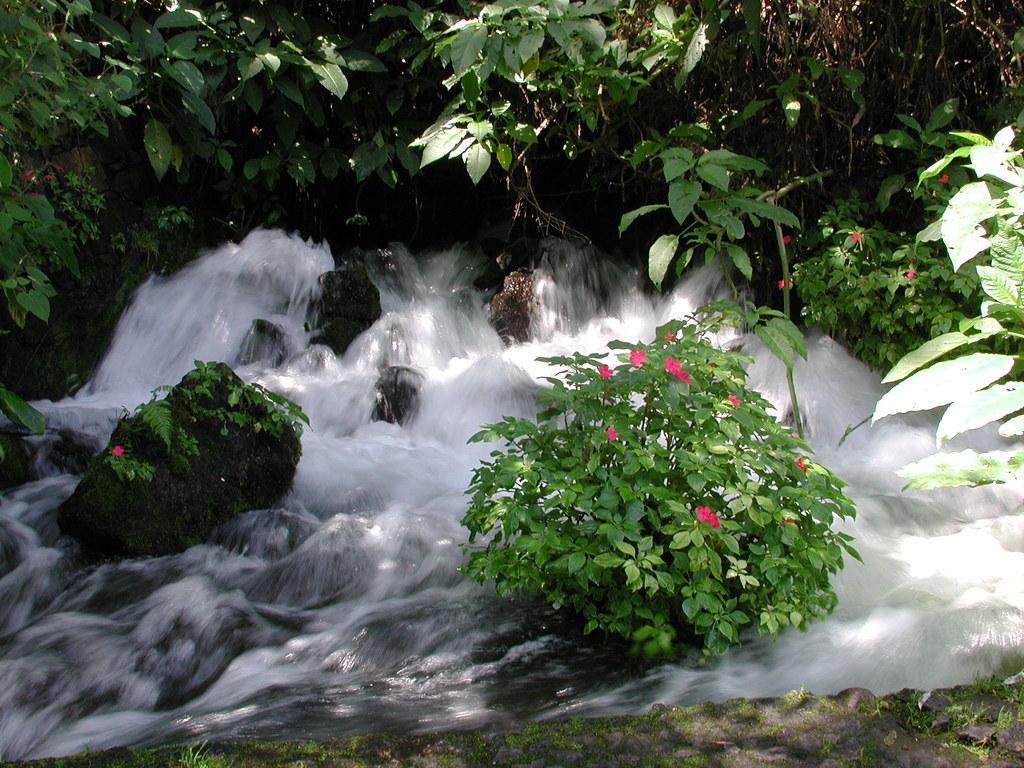What natural feature is the main subject of the image? There is a waterfall in the image. What type of vegetation can be seen in the image? There are trees and plants with flowers in the image. What type of sugar is being used to create harmony in the image? There is no sugar or reference to harmony in the image; it features a waterfall, trees, and plants with flowers. 